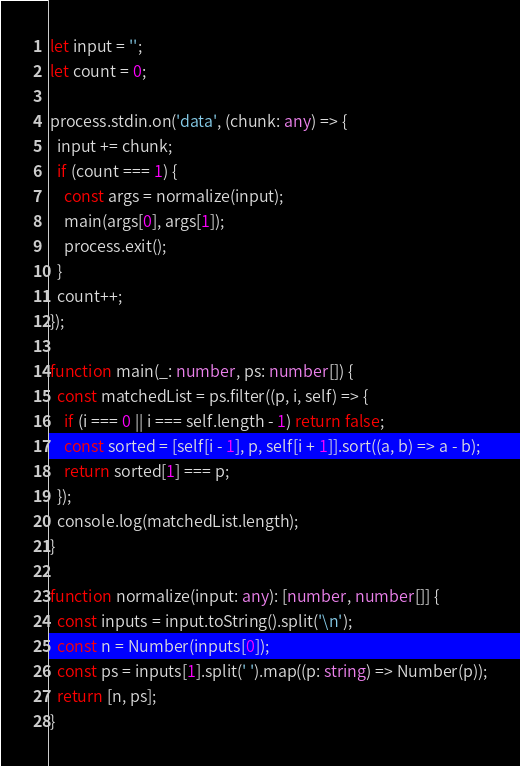<code> <loc_0><loc_0><loc_500><loc_500><_TypeScript_>let input = '';
let count = 0;

process.stdin.on('data', (chunk: any) => {
  input += chunk;
  if (count === 1) {
    const args = normalize(input);
    main(args[0], args[1]);
    process.exit();
  }
  count++;
});

function main(_: number, ps: number[]) {
  const matchedList = ps.filter((p, i, self) => {
    if (i === 0 || i === self.length - 1) return false;
    const sorted = [self[i - 1], p, self[i + 1]].sort((a, b) => a - b);
    return sorted[1] === p;
  });
  console.log(matchedList.length);
}

function normalize(input: any): [number, number[]] {
  const inputs = input.toString().split('\n');
  const n = Number(inputs[0]);
  const ps = inputs[1].split(' ').map((p: string) => Number(p));
  return [n, ps];
}
</code> 